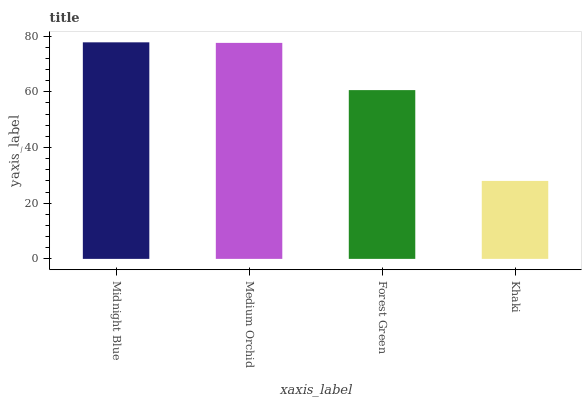Is Khaki the minimum?
Answer yes or no. Yes. Is Midnight Blue the maximum?
Answer yes or no. Yes. Is Medium Orchid the minimum?
Answer yes or no. No. Is Medium Orchid the maximum?
Answer yes or no. No. Is Midnight Blue greater than Medium Orchid?
Answer yes or no. Yes. Is Medium Orchid less than Midnight Blue?
Answer yes or no. Yes. Is Medium Orchid greater than Midnight Blue?
Answer yes or no. No. Is Midnight Blue less than Medium Orchid?
Answer yes or no. No. Is Medium Orchid the high median?
Answer yes or no. Yes. Is Forest Green the low median?
Answer yes or no. Yes. Is Midnight Blue the high median?
Answer yes or no. No. Is Midnight Blue the low median?
Answer yes or no. No. 